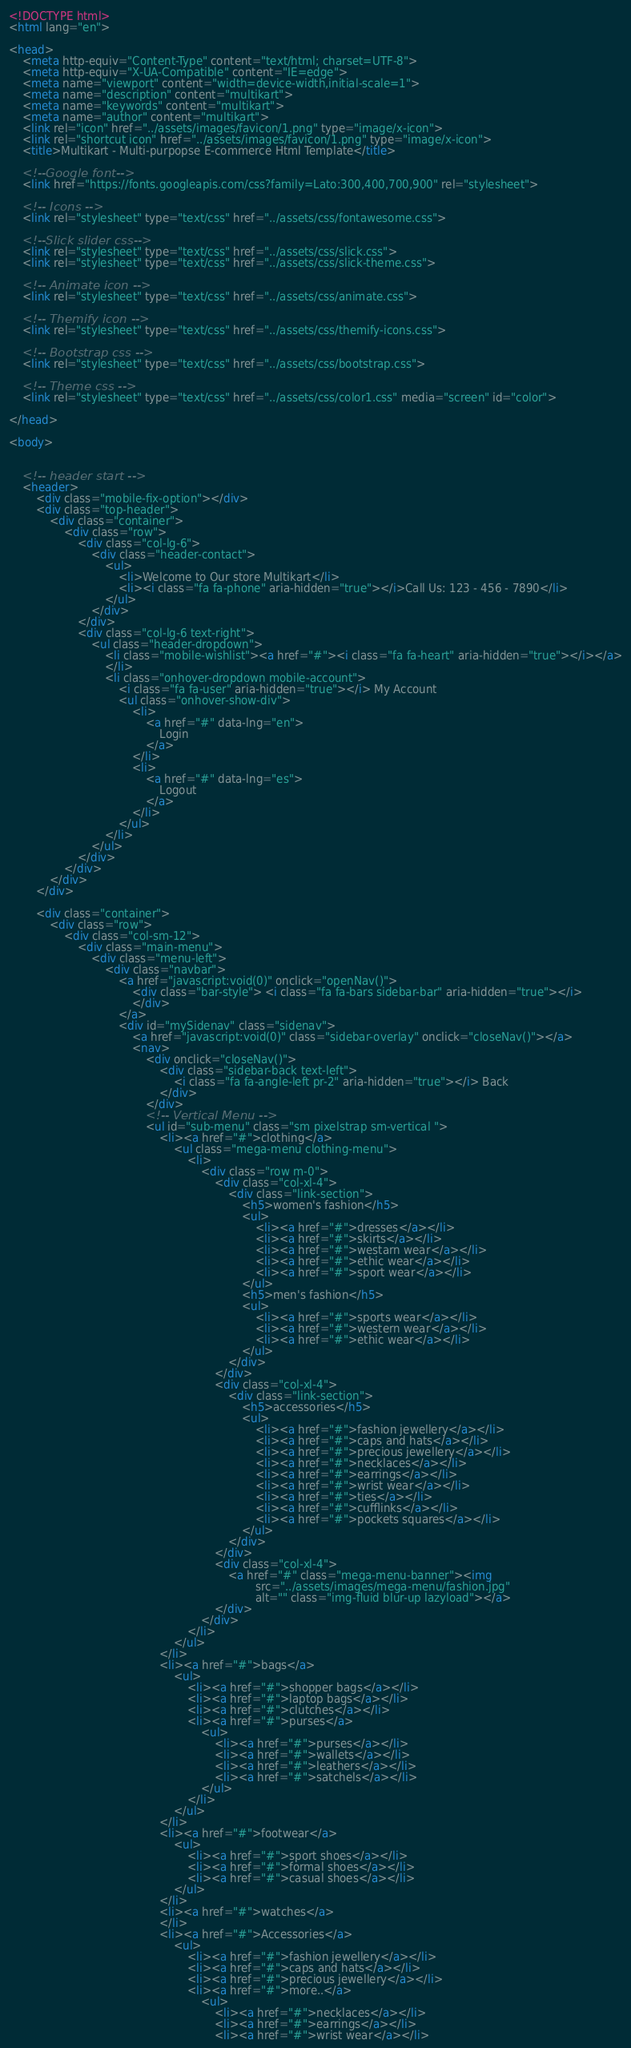<code> <loc_0><loc_0><loc_500><loc_500><_HTML_><!DOCTYPE html>
<html lang="en">

<head>
    <meta http-equiv="Content-Type" content="text/html; charset=UTF-8">
    <meta http-equiv="X-UA-Compatible" content="IE=edge">
    <meta name="viewport" content="width=device-width,initial-scale=1">
    <meta name="description" content="multikart">
    <meta name="keywords" content="multikart">
    <meta name="author" content="multikart">
    <link rel="icon" href="../assets/images/favicon/1.png" type="image/x-icon">
    <link rel="shortcut icon" href="../assets/images/favicon/1.png" type="image/x-icon">
    <title>Multikart - Multi-purpopse E-commerce Html Template</title>

    <!--Google font-->
    <link href="https://fonts.googleapis.com/css?family=Lato:300,400,700,900" rel="stylesheet">

    <!-- Icons -->
    <link rel="stylesheet" type="text/css" href="../assets/css/fontawesome.css">

    <!--Slick slider css-->
    <link rel="stylesheet" type="text/css" href="../assets/css/slick.css">
    <link rel="stylesheet" type="text/css" href="../assets/css/slick-theme.css">

    <!-- Animate icon -->
    <link rel="stylesheet" type="text/css" href="../assets/css/animate.css">

    <!-- Themify icon -->
    <link rel="stylesheet" type="text/css" href="../assets/css/themify-icons.css">

    <!-- Bootstrap css -->
    <link rel="stylesheet" type="text/css" href="../assets/css/bootstrap.css">

    <!-- Theme css -->
    <link rel="stylesheet" type="text/css" href="../assets/css/color1.css" media="screen" id="color">

</head>

<body>


    <!-- header start -->
    <header>
        <div class="mobile-fix-option"></div>
        <div class="top-header">
            <div class="container">
                <div class="row">
                    <div class="col-lg-6">
                        <div class="header-contact">
                            <ul>
                                <li>Welcome to Our store Multikart</li>
                                <li><i class="fa fa-phone" aria-hidden="true"></i>Call Us: 123 - 456 - 7890</li>
                            </ul>
                        </div>
                    </div>
                    <div class="col-lg-6 text-right">
                        <ul class="header-dropdown">
                            <li class="mobile-wishlist"><a href="#"><i class="fa fa-heart" aria-hidden="true"></i></a>
                            </li>
                            <li class="onhover-dropdown mobile-account">
                                <i class="fa fa-user" aria-hidden="true"></i> My Account
                                <ul class="onhover-show-div">
                                    <li>
                                        <a href="#" data-lng="en">
                                            Login
                                        </a>
                                    </li>
                                    <li>
                                        <a href="#" data-lng="es">
                                            Logout
                                        </a>
                                    </li>
                                </ul>
                            </li>
                        </ul>
                    </div>
                </div>
            </div>
        </div>

        <div class="container">
            <div class="row">
                <div class="col-sm-12">
                    <div class="main-menu">
                        <div class="menu-left">
                            <div class="navbar">
                                <a href="javascript:void(0)" onclick="openNav()">
                                    <div class="bar-style"> <i class="fa fa-bars sidebar-bar" aria-hidden="true"></i>
                                    </div>
                                </a>
                                <div id="mySidenav" class="sidenav">
                                    <a href="javascript:void(0)" class="sidebar-overlay" onclick="closeNav()"></a>
                                    <nav>
                                        <div onclick="closeNav()">
                                            <div class="sidebar-back text-left">
                                                <i class="fa fa-angle-left pr-2" aria-hidden="true"></i> Back
                                            </div>
                                        </div>
                                        <!-- Vertical Menu -->
                                        <ul id="sub-menu" class="sm pixelstrap sm-vertical ">
                                            <li><a href="#">clothing</a>
                                                <ul class="mega-menu clothing-menu">
                                                    <li>
                                                        <div class="row m-0">
                                                            <div class="col-xl-4">
                                                                <div class="link-section">
                                                                    <h5>women's fashion</h5>
                                                                    <ul>
                                                                        <li><a href="#">dresses</a></li>
                                                                        <li><a href="#">skirts</a></li>
                                                                        <li><a href="#">westarn wear</a></li>
                                                                        <li><a href="#">ethic wear</a></li>
                                                                        <li><a href="#">sport wear</a></li>
                                                                    </ul>
                                                                    <h5>men's fashion</h5>
                                                                    <ul>
                                                                        <li><a href="#">sports wear</a></li>
                                                                        <li><a href="#">western wear</a></li>
                                                                        <li><a href="#">ethic wear</a></li>
                                                                    </ul>
                                                                </div>
                                                            </div>
                                                            <div class="col-xl-4">
                                                                <div class="link-section">
                                                                    <h5>accessories</h5>
                                                                    <ul>
                                                                        <li><a href="#">fashion jewellery</a></li>
                                                                        <li><a href="#">caps and hats</a></li>
                                                                        <li><a href="#">precious jewellery</a></li>
                                                                        <li><a href="#">necklaces</a></li>
                                                                        <li><a href="#">earrings</a></li>
                                                                        <li><a href="#">wrist wear</a></li>
                                                                        <li><a href="#">ties</a></li>
                                                                        <li><a href="#">cufflinks</a></li>
                                                                        <li><a href="#">pockets squares</a></li>
                                                                    </ul>
                                                                </div>
                                                            </div>
                                                            <div class="col-xl-4">
                                                                <a href="#" class="mega-menu-banner"><img
                                                                        src="../assets/images/mega-menu/fashion.jpg"
                                                                        alt="" class="img-fluid blur-up lazyload"></a>
                                                            </div>
                                                        </div>
                                                    </li>
                                                </ul>
                                            </li>
                                            <li><a href="#">bags</a>
                                                <ul>
                                                    <li><a href="#">shopper bags</a></li>
                                                    <li><a href="#">laptop bags</a></li>
                                                    <li><a href="#">clutches</a></li>
                                                    <li><a href="#">purses</a>
                                                        <ul>
                                                            <li><a href="#">purses</a></li>
                                                            <li><a href="#">wallets</a></li>
                                                            <li><a href="#">leathers</a></li>
                                                            <li><a href="#">satchels</a></li>
                                                        </ul>
                                                    </li>
                                                </ul>
                                            </li>
                                            <li><a href="#">footwear</a>
                                                <ul>
                                                    <li><a href="#">sport shoes</a></li>
                                                    <li><a href="#">formal shoes</a></li>
                                                    <li><a href="#">casual shoes</a></li>
                                                </ul>
                                            </li>
                                            <li><a href="#">watches</a>
                                            </li>
                                            <li><a href="#">Accessories</a>
                                                <ul>
                                                    <li><a href="#">fashion jewellery</a></li>
                                                    <li><a href="#">caps and hats</a></li>
                                                    <li><a href="#">precious jewellery</a></li>
                                                    <li><a href="#">more..</a>
                                                        <ul>
                                                            <li><a href="#">necklaces</a></li>
                                                            <li><a href="#">earrings</a></li>
                                                            <li><a href="#">wrist wear</a></li></code> 